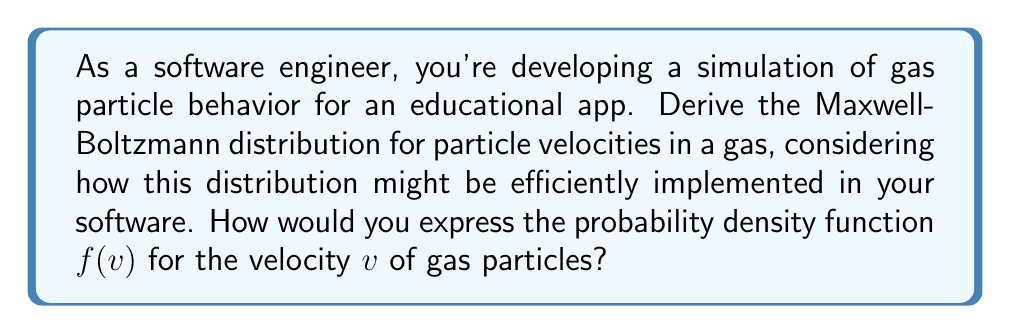Solve this math problem. Let's derive the Maxwell-Boltzmann distribution step-by-step:

1) We start with the Boltzmann distribution for energy:

   $$P(E) \propto e^{-E/kT}$$

   where $k$ is Boltzmann's constant and $T$ is temperature.

2) For a particle of mass $m$, the kinetic energy is:

   $$E = \frac{1}{2}mv^2$$

3) Substituting this into the Boltzmann distribution:

   $$P(v) \propto e^{-mv^2/2kT}$$

4) We need to consider the 3D nature of velocity. The number of particles with velocity between $v$ and $v + dv$ is proportional to the surface area of a sphere with radius $v$ in velocity space:

   $$N(v) \propto 4\pi v^2 \cdot e^{-mv^2/2kT}$$

5) To get the probability density function, we normalize this distribution:

   $$f(v) = A \cdot v^2 e^{-mv^2/2kT}$$

   where $A$ is a normalization constant.

6) To find $A$, we integrate $f(v)$ over all possible velocities and set it equal to 1:

   $$\int_0^\infty f(v) dv = 1$$

7) Solving this integral (which involves a Gaussian integral) gives us:

   $$A = 4\pi \left(\frac{m}{2\pi kT}\right)^{3/2}$$

8) Therefore, the final Maxwell-Boltzmann distribution is:

   $$f(v) = 4\pi \left(\frac{m}{2\pi kT}\right)^{3/2} v^2 e^{-mv^2/2kT}$$

This function gives the probability density for a particle to have a speed $v$ at temperature $T$.
Answer: $$f(v) = 4\pi \left(\frac{m}{2\pi kT}\right)^{3/2} v^2 e^{-mv^2/2kT}$$ 